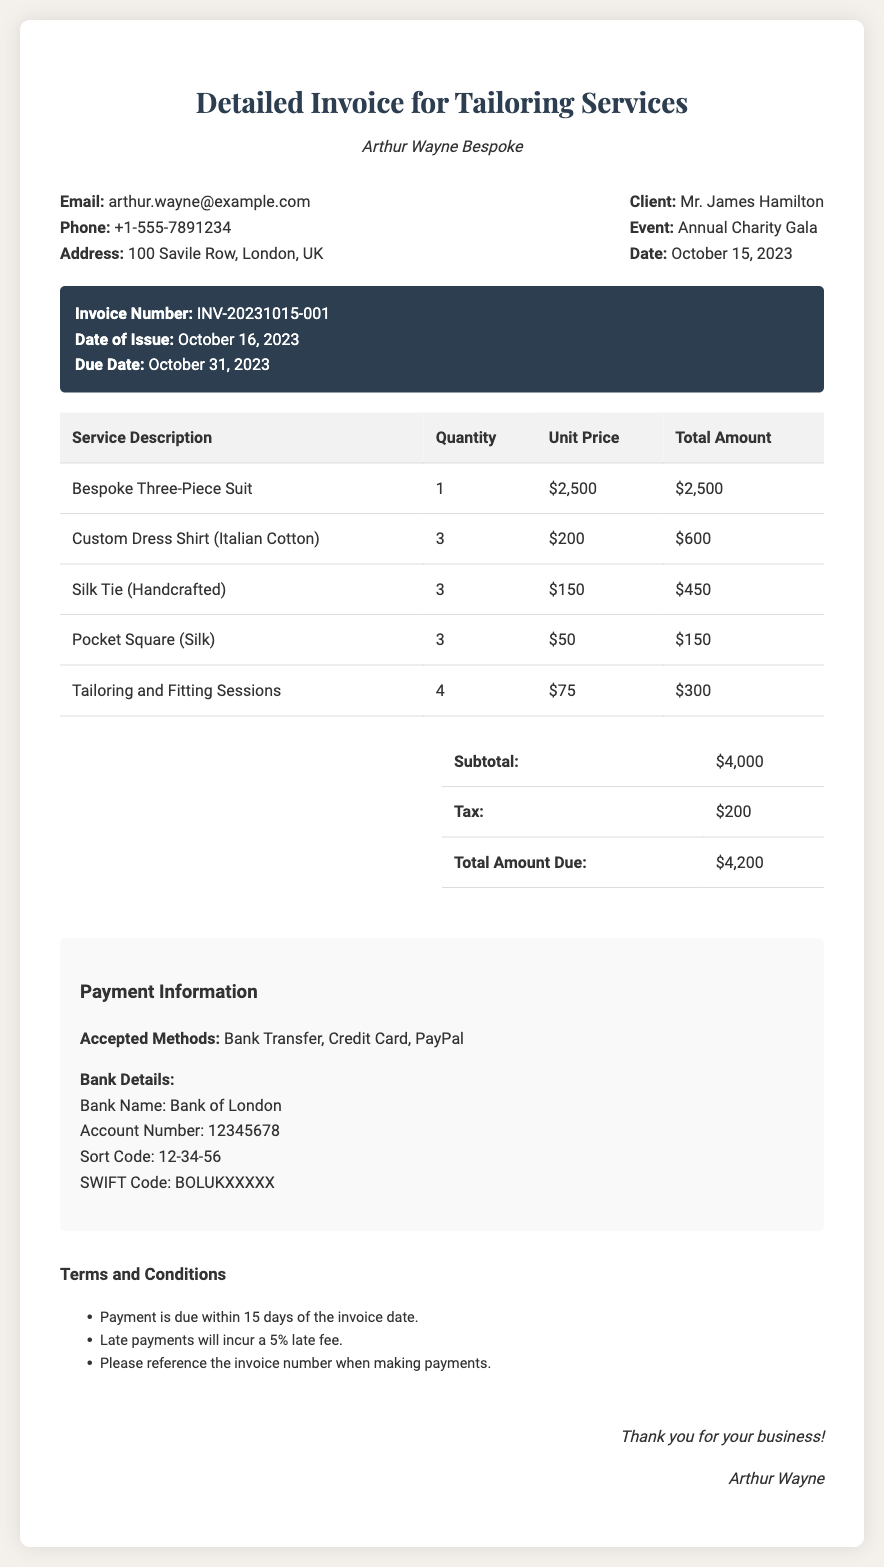What is the name of the designer? The designer's name is mentioned at the top of the document, identifying him as Arthur Wayne.
Answer: Arthur Wayne Who is the client? The name of the client is provided in the contact information section of the document.
Answer: Mr. James Hamilton What is the total amount due? The total amount due is found in the summary table under the "Total Amount Due" section.
Answer: $4,200 What is the invoice number? The invoice number is specified in the invoice details section of the document.
Answer: INV-20231015-001 How many bespoke three-piece suits were ordered? The quantity of bespoke three-piece suits can be found in the service description table.
Answer: 1 What is the date of the event? The event date is stated in the client information section of the document.
Answer: October 15, 2023 What are the accepted payment methods? The accepted methods are listed in the payment information section of the document.
Answer: Bank Transfer, Credit Card, PayPal How much was charged for tailoring and fitting sessions? The total charge can be calculated or retrieved directly from the service description table.
Answer: $300 What is the due date for payment? The due date for payment is mentioned in the invoice details section.
Answer: October 31, 2023 